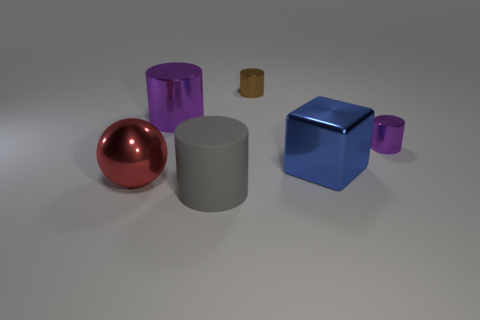Subtract all small purple metal cylinders. How many cylinders are left? 3 Subtract all purple cylinders. How many cylinders are left? 2 Add 4 big blue blocks. How many big blue blocks are left? 5 Add 3 large gray objects. How many large gray objects exist? 4 Add 3 big brown shiny cubes. How many objects exist? 9 Subtract 0 brown balls. How many objects are left? 6 Subtract all balls. How many objects are left? 5 Subtract 2 cylinders. How many cylinders are left? 2 Subtract all brown cylinders. Subtract all green cubes. How many cylinders are left? 3 Subtract all cyan spheres. How many gray cubes are left? 0 